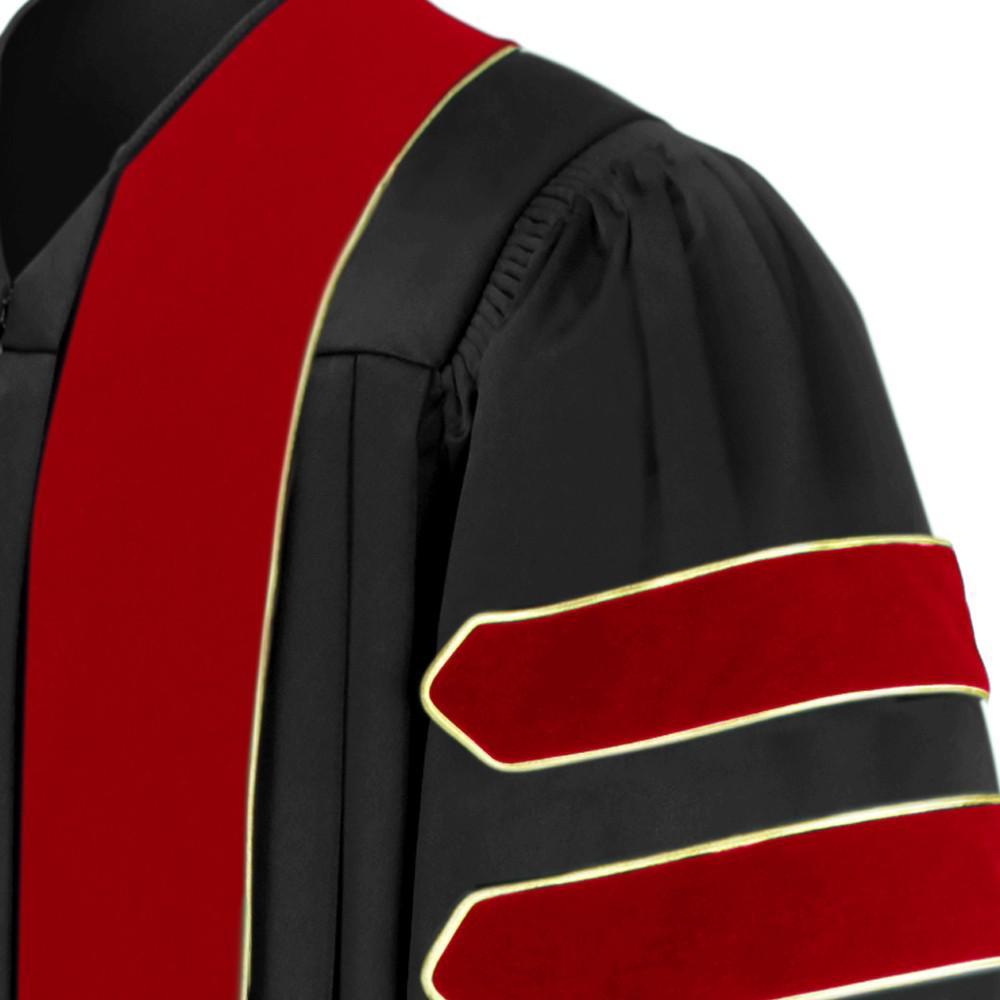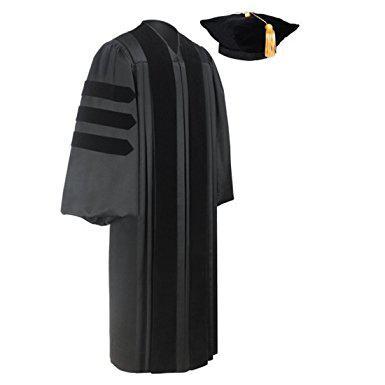The first image is the image on the left, the second image is the image on the right. Given the left and right images, does the statement "One image shows a purple and black gown angled facing slightly rightward." hold true? Answer yes or no. No. The first image is the image on the left, the second image is the image on the right. Considering the images on both sides, is "There is at least one unworn academic gown facing slightly to the right." valid? Answer yes or no. Yes. 